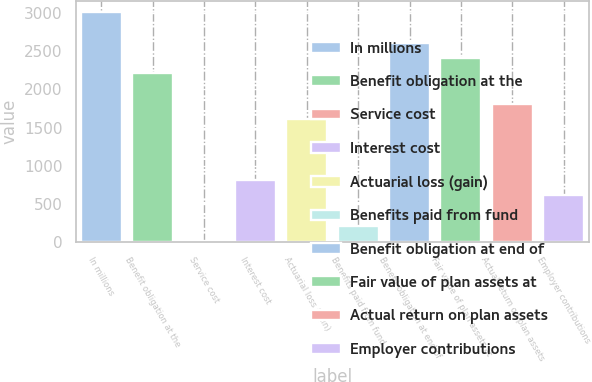<chart> <loc_0><loc_0><loc_500><loc_500><bar_chart><fcel>In millions<fcel>Benefit obligation at the<fcel>Service cost<fcel>Interest cost<fcel>Actuarial loss (gain)<fcel>Benefits paid from fund<fcel>Benefit obligation at end of<fcel>Fair value of plan assets at<fcel>Actual return on plan assets<fcel>Employer contributions<nl><fcel>3009<fcel>2212.2<fcel>21<fcel>817.8<fcel>1614.6<fcel>220.2<fcel>2610.6<fcel>2411.4<fcel>1813.8<fcel>618.6<nl></chart> 